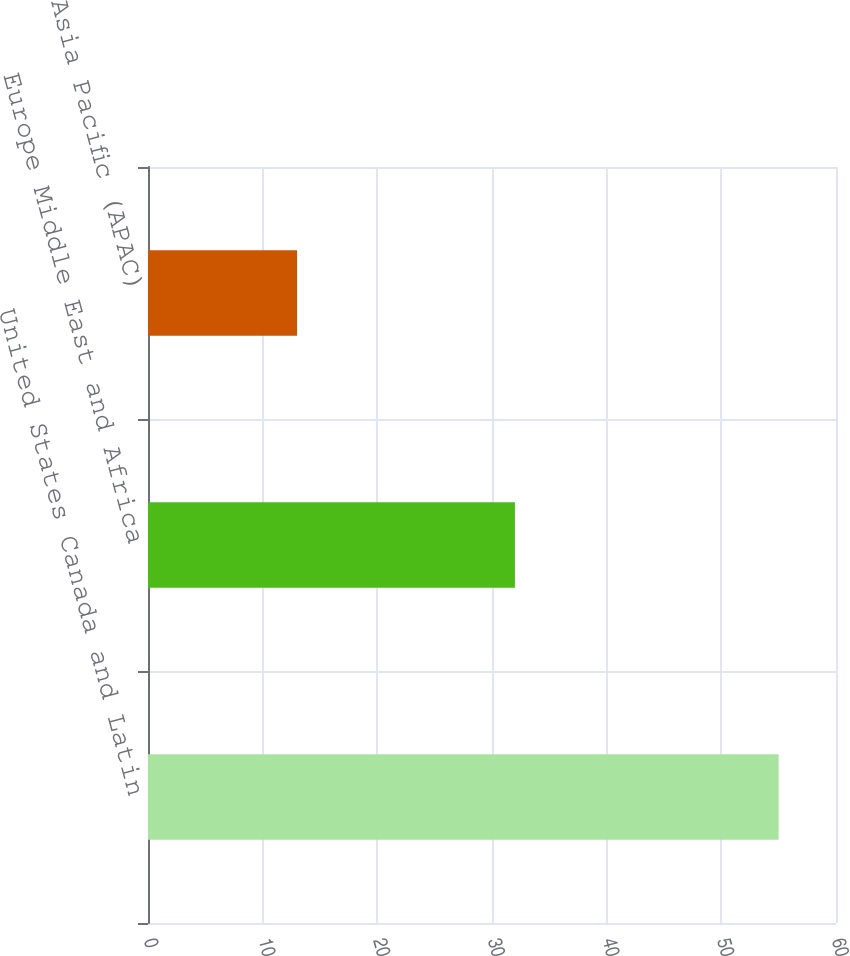Convert chart. <chart><loc_0><loc_0><loc_500><loc_500><bar_chart><fcel>United States Canada and Latin<fcel>Europe Middle East and Africa<fcel>Asia Pacific (APAC)<nl><fcel>55<fcel>32<fcel>13<nl></chart> 